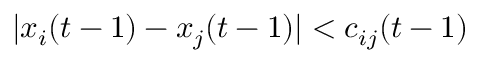<formula> <loc_0><loc_0><loc_500><loc_500>| x _ { i } ( t - 1 ) - x _ { j } ( t - 1 ) | < c _ { i j } ( t - 1 )</formula> 